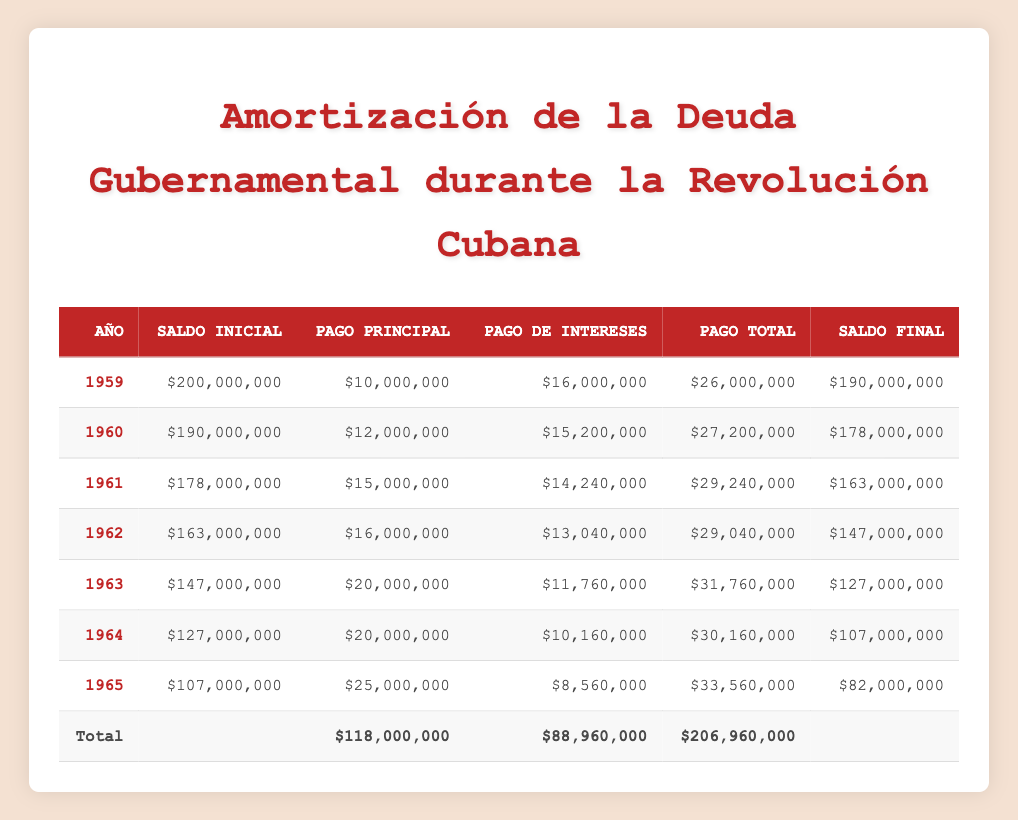¿Cuál fue el saldo inicial en 1961? En la tabla, busco la fila correspondiente al año 1961 y encuentro que el saldo inicial es de 178,000,000.
Answer: 178,000,000 ¿Cuánto se pagó en total en 1963? En la fila del año 1963, reviso la columna del pago total, que indica que se pagaron 31,760,000.
Answer: 31,760,000 ¿El pago de intereses en 1965 fue menor que en 1964? Comparo los valores del pago de intereses para ambos años: en 1965 fue 8,560,000 y en 1964 fue 10,160,000. Como 8,560,000 es menor que 10,160,000, la afirmación es verdadera.
Answer: Sí ¿Cuál fue el aumento total en los pagos de principal de 1959 a 1965? Sumando los pagos de principal desde 1959 hasta 1965: 10,000,000 + 12,000,000 + 15,000,000 + 16,000,000 + 20,000,000 + 20,000,000 + 25,000,000 = 118,000,000. Este es el total de pagos de principal.
Answer: 118,000,000 ¿Qué año tuvo el mayor saldo final y cuál fue ese saldo? Reviso la columna del saldo final y encuentro que 1965 tuvo el saldo más bajo con 82,000,000, mientras que 1959 tuvo el saldo final más alto de 190,000,000. Así que el año con el mayor saldo final es 1959.
Answer: 1959, 190,000,000 ¿Cuál fue el promedio de pagos de intereses durante este período? Tomo todos los pagos de intereses y los sumo: 16,000,000 + 15,200,000 + 14,240,000 + 13,040,000 + 11,760,000 + 10,160,000 + 8,560,000 = 88,960,000. Luego divido el total entre 7 (los años): 88,960,000 / 7 = 12,694,285.71.
Answer: 12,694,285.71 ¿Los pagos totales fueron siempre superiores a los pagos de intereses? Evaluando los pagos totales y los pagos de intereses de cada año, confirmo que en todos los casos, los pagos totales superaron a los pagos de intereses.
Answer: Sí ¿Cuál fue la disminución del saldo de la deuda entre los años 1960 y 1961? En 1960, el saldo final fue de 178,000,000 y el saldo final en 1960 fue de 190,000,000. Para calcular la disminución: 190,000,000 - 178,000,000 = 12,000,000.
Answer: 12,000,000 